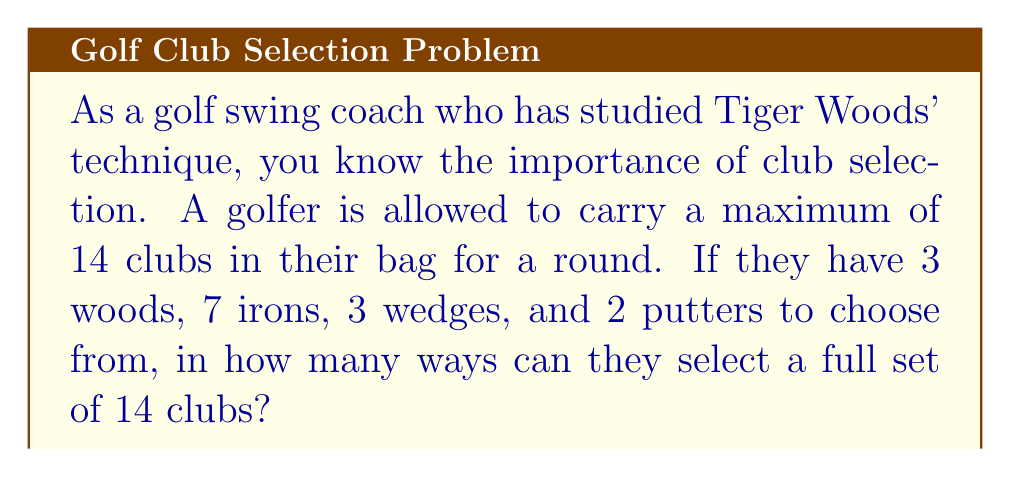Give your solution to this math problem. Let's approach this step-by-step using the combination formula:

1) We need to select:
   - All 3 woods (no choice here)
   - Some number of irons out of 7
   - Some number of wedges out of 3
   - 1 or 2 putters

2) Since we must select 14 clubs in total, and we're forced to take all 3 woods, we need to select 11 more clubs from the remaining options.

3) Let $i$ be the number of irons selected, $w$ be the number of wedges, and $p$ be the number of putters. We have the equation:

   $i + w + p = 11$

4) We know that $0 \leq i \leq 7$, $0 \leq w \leq 3$, and $1 \leq p \leq 2$.

5) For each valid combination of $i$, $w$, and $p$, we need to calculate:

   $$\binom{7}{i} \cdot \binom{3}{w} \cdot \binom{2}{p}$$

6) The valid combinations are:
   - 7 irons, 3 wedges, 1 putter
   - 6 irons, 3 wedges, 2 putters
   - 7 irons, 2 wedges, 2 putters

7) Let's calculate each:
   - $\binom{7}{7} \cdot \binom{3}{3} \cdot \binom{2}{1} = 1 \cdot 1 \cdot 2 = 2$
   - $\binom{7}{6} \cdot \binom{3}{3} \cdot \binom{2}{2} = 7 \cdot 1 \cdot 1 = 7$
   - $\binom{7}{7} \cdot \binom{3}{2} \cdot \binom{2}{2} = 1 \cdot 3 \cdot 1 = 3$

8) The total number of ways is the sum of these: $2 + 7 + 3 = 12$
Answer: 12 